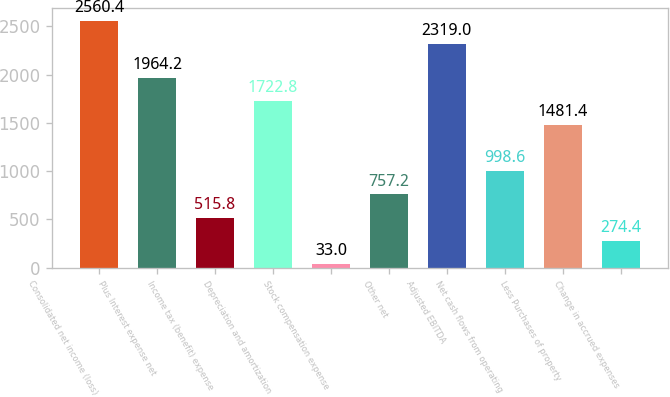Convert chart to OTSL. <chart><loc_0><loc_0><loc_500><loc_500><bar_chart><fcel>Consolidated net income (loss)<fcel>Plus Interest expense net<fcel>Income tax (benefit) expense<fcel>Depreciation and amortization<fcel>Stock compensation expense<fcel>Other net<fcel>Adjusted EBITDA<fcel>Net cash flows from operating<fcel>Less Purchases of property<fcel>Change in accrued expenses<nl><fcel>2560.4<fcel>1964.2<fcel>515.8<fcel>1722.8<fcel>33<fcel>757.2<fcel>2319<fcel>998.6<fcel>1481.4<fcel>274.4<nl></chart> 